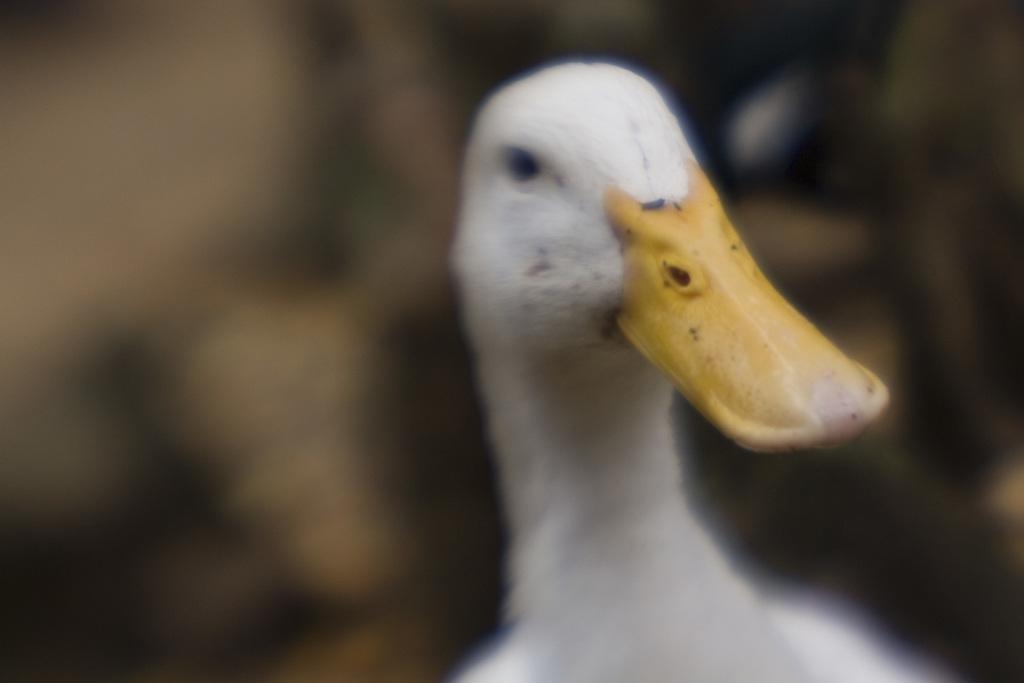What is the main subject of the image? There is a duck in the center of the image. Can you describe the background of the image? The background of the image is blurry. What is the price of the mitten in the image? There is no mitten present in the image, so it is not possible to determine its price. 